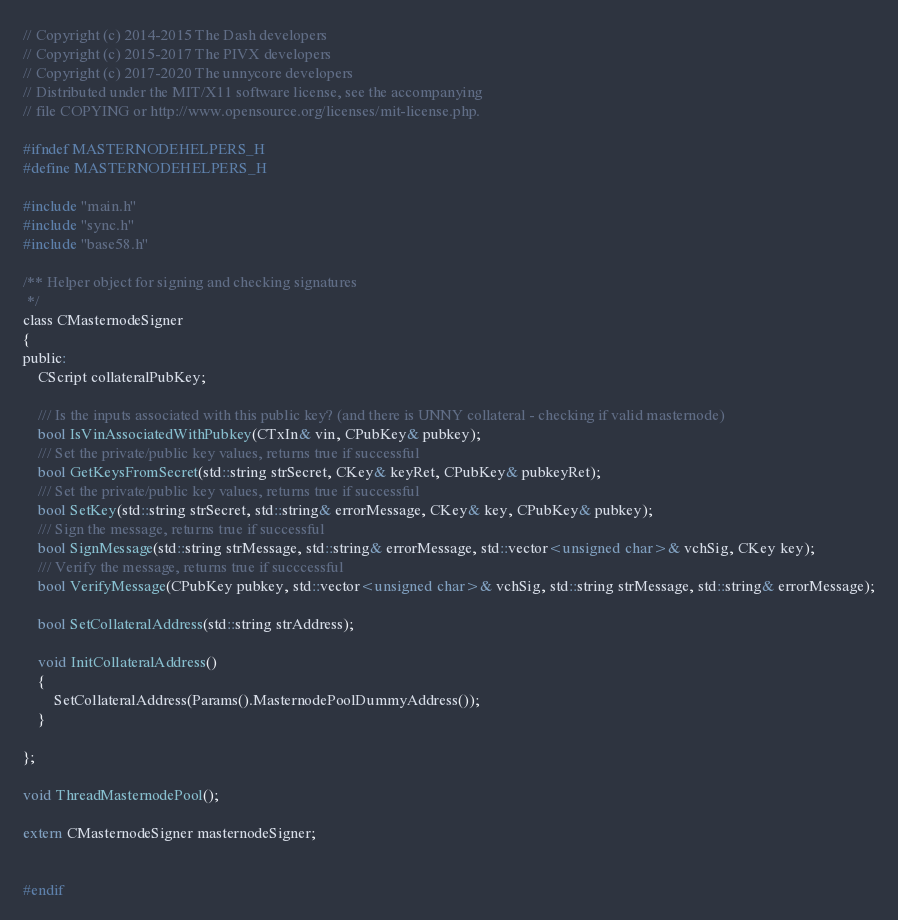Convert code to text. <code><loc_0><loc_0><loc_500><loc_500><_C_>// Copyright (c) 2014-2015 The Dash developers
// Copyright (c) 2015-2017 The PIVX developers
// Copyright (c) 2017-2020 The unnycore developers
// Distributed under the MIT/X11 software license, see the accompanying
// file COPYING or http://www.opensource.org/licenses/mit-license.php.

#ifndef MASTERNODEHELPERS_H
#define MASTERNODEHELPERS_H

#include "main.h"
#include "sync.h"
#include "base58.h"

/** Helper object for signing and checking signatures
 */
class CMasternodeSigner
{
public:
    CScript collateralPubKey;

    /// Is the inputs associated with this public key? (and there is UNNY collateral - checking if valid masternode)
    bool IsVinAssociatedWithPubkey(CTxIn& vin, CPubKey& pubkey);
    /// Set the private/public key values, returns true if successful
    bool GetKeysFromSecret(std::string strSecret, CKey& keyRet, CPubKey& pubkeyRet);
    /// Set the private/public key values, returns true if successful
    bool SetKey(std::string strSecret, std::string& errorMessage, CKey& key, CPubKey& pubkey);
    /// Sign the message, returns true if successful
    bool SignMessage(std::string strMessage, std::string& errorMessage, std::vector<unsigned char>& vchSig, CKey key);
    /// Verify the message, returns true if succcessful
    bool VerifyMessage(CPubKey pubkey, std::vector<unsigned char>& vchSig, std::string strMessage, std::string& errorMessage);

    bool SetCollateralAddress(std::string strAddress);

    void InitCollateralAddress()
    {
        SetCollateralAddress(Params().MasternodePoolDummyAddress());
    }

};

void ThreadMasternodePool();

extern CMasternodeSigner masternodeSigner;


#endif
</code> 